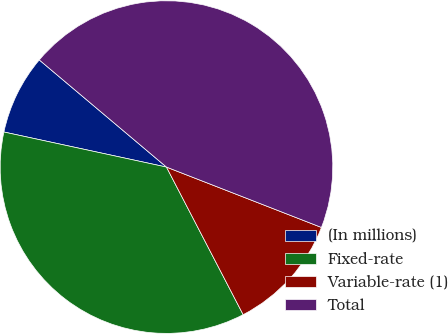Convert chart. <chart><loc_0><loc_0><loc_500><loc_500><pie_chart><fcel>(In millions)<fcel>Fixed-rate<fcel>Variable-rate (1)<fcel>Total<nl><fcel>7.76%<fcel>36.01%<fcel>11.46%<fcel>44.77%<nl></chart> 